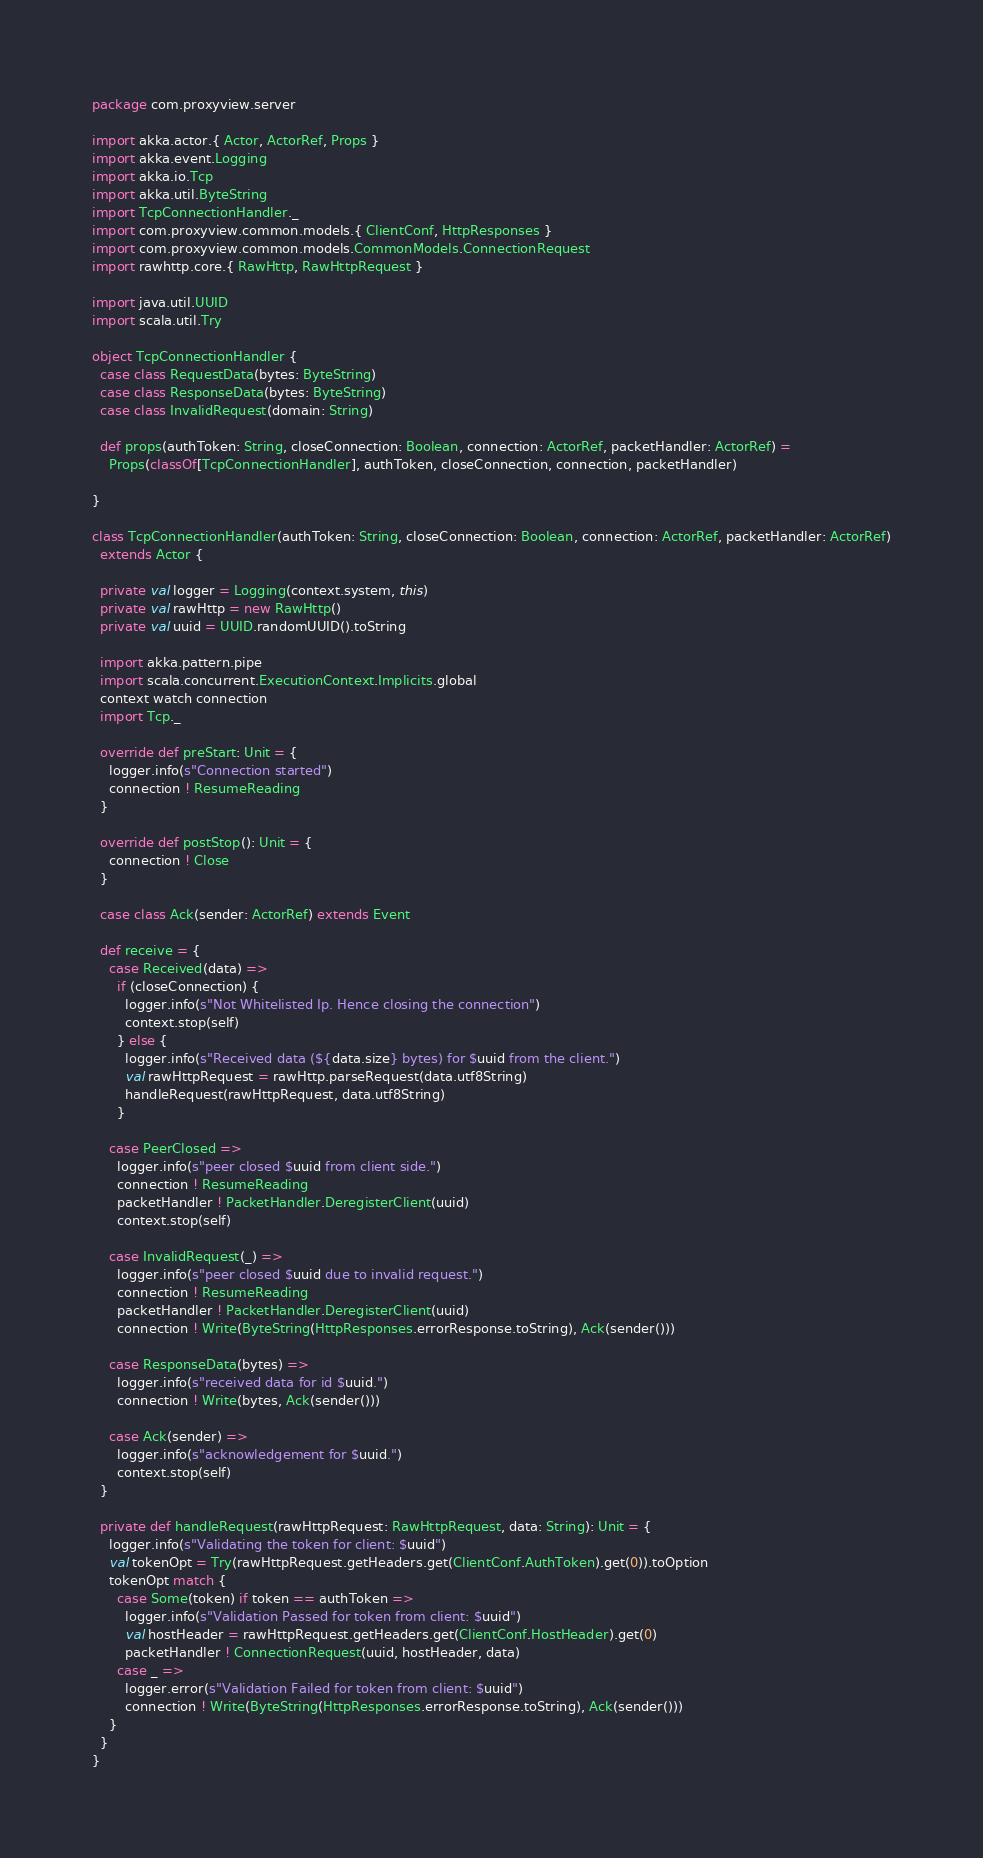Convert code to text. <code><loc_0><loc_0><loc_500><loc_500><_Scala_>package com.proxyview.server

import akka.actor.{ Actor, ActorRef, Props }
import akka.event.Logging
import akka.io.Tcp
import akka.util.ByteString
import TcpConnectionHandler._
import com.proxyview.common.models.{ ClientConf, HttpResponses }
import com.proxyview.common.models.CommonModels.ConnectionRequest
import rawhttp.core.{ RawHttp, RawHttpRequest }

import java.util.UUID
import scala.util.Try

object TcpConnectionHandler {
  case class RequestData(bytes: ByteString)
  case class ResponseData(bytes: ByteString)
  case class InvalidRequest(domain: String)

  def props(authToken: String, closeConnection: Boolean, connection: ActorRef, packetHandler: ActorRef) =
    Props(classOf[TcpConnectionHandler], authToken, closeConnection, connection, packetHandler)

}

class TcpConnectionHandler(authToken: String, closeConnection: Boolean, connection: ActorRef, packetHandler: ActorRef)
  extends Actor {

  private val logger = Logging(context.system, this)
  private val rawHttp = new RawHttp()
  private val uuid = UUID.randomUUID().toString

  import akka.pattern.pipe
  import scala.concurrent.ExecutionContext.Implicits.global
  context watch connection
  import Tcp._

  override def preStart: Unit = {
    logger.info(s"Connection started")
    connection ! ResumeReading
  }

  override def postStop(): Unit = {
    connection ! Close
  }

  case class Ack(sender: ActorRef) extends Event

  def receive = {
    case Received(data) =>
      if (closeConnection) {
        logger.info(s"Not Whitelisted Ip. Hence closing the connection")
        context.stop(self)
      } else {
        logger.info(s"Received data (${data.size} bytes) for $uuid from the client.")
        val rawHttpRequest = rawHttp.parseRequest(data.utf8String)
        handleRequest(rawHttpRequest, data.utf8String)
      }

    case PeerClosed =>
      logger.info(s"peer closed $uuid from client side.")
      connection ! ResumeReading
      packetHandler ! PacketHandler.DeregisterClient(uuid)
      context.stop(self)

    case InvalidRequest(_) =>
      logger.info(s"peer closed $uuid due to invalid request.")
      connection ! ResumeReading
      packetHandler ! PacketHandler.DeregisterClient(uuid)
      connection ! Write(ByteString(HttpResponses.errorResponse.toString), Ack(sender()))

    case ResponseData(bytes) =>
      logger.info(s"received data for id $uuid.")
      connection ! Write(bytes, Ack(sender()))

    case Ack(sender) =>
      logger.info(s"acknowledgement for $uuid.")
      context.stop(self)
  }

  private def handleRequest(rawHttpRequest: RawHttpRequest, data: String): Unit = {
    logger.info(s"Validating the token for client: $uuid")
    val tokenOpt = Try(rawHttpRequest.getHeaders.get(ClientConf.AuthToken).get(0)).toOption
    tokenOpt match {
      case Some(token) if token == authToken =>
        logger.info(s"Validation Passed for token from client: $uuid")
        val hostHeader = rawHttpRequest.getHeaders.get(ClientConf.HostHeader).get(0)
        packetHandler ! ConnectionRequest(uuid, hostHeader, data)
      case _ =>
        logger.error(s"Validation Failed for token from client: $uuid")
        connection ! Write(ByteString(HttpResponses.errorResponse.toString), Ack(sender()))
    }
  }
}
</code> 